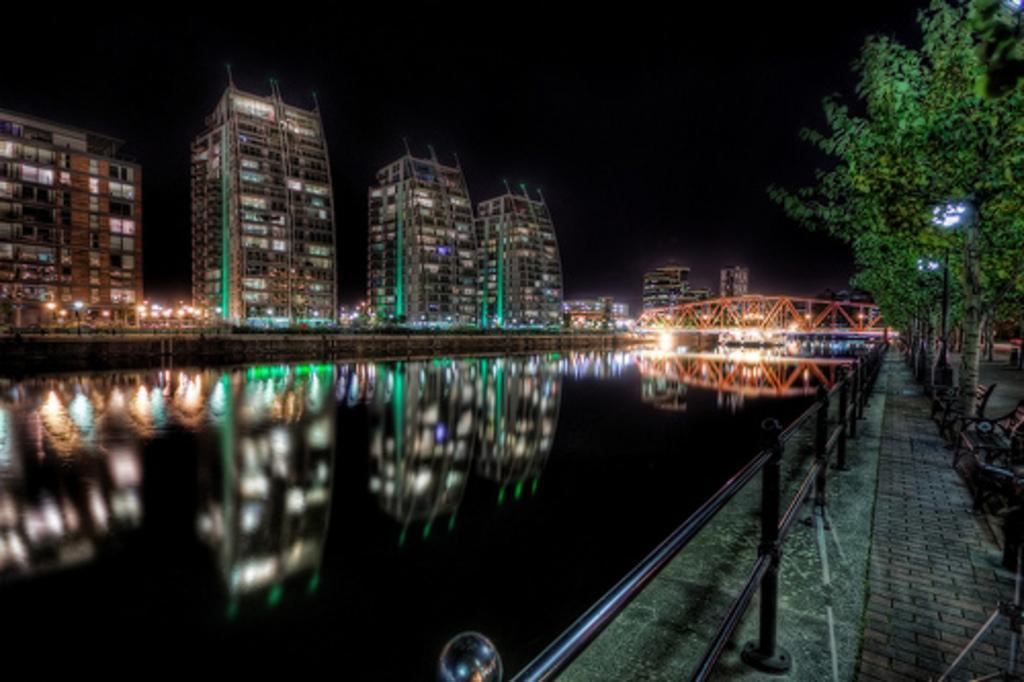Can you describe this image briefly? In this image there is a lake and a bridge built over it, to its left there are buildings and to its right there are trees, benches and street lights. 